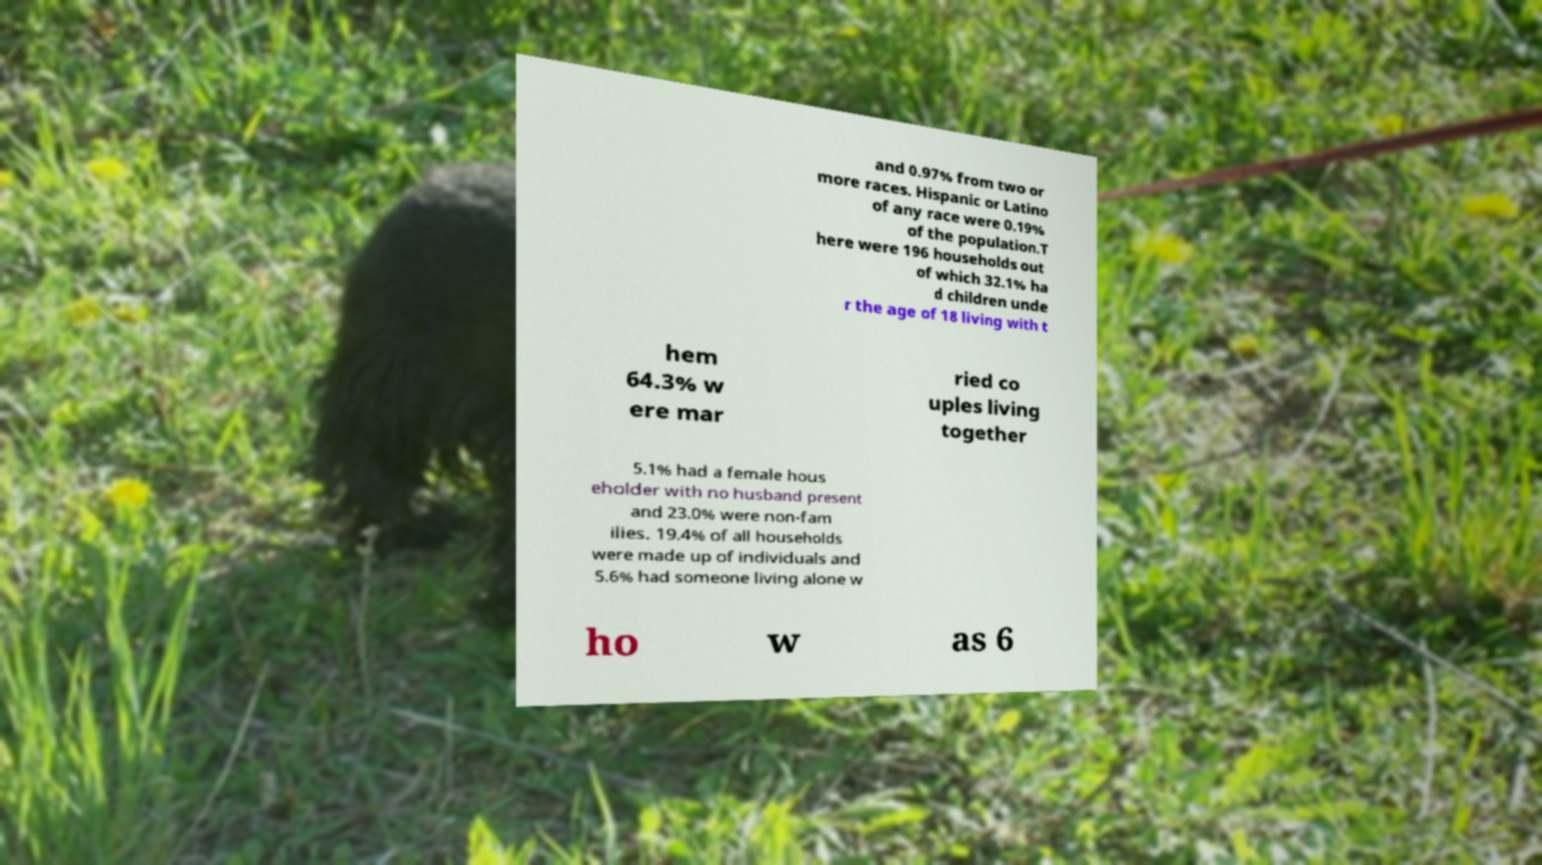Can you accurately transcribe the text from the provided image for me? and 0.97% from two or more races. Hispanic or Latino of any race were 0.19% of the population.T here were 196 households out of which 32.1% ha d children unde r the age of 18 living with t hem 64.3% w ere mar ried co uples living together 5.1% had a female hous eholder with no husband present and 23.0% were non-fam ilies. 19.4% of all households were made up of individuals and 5.6% had someone living alone w ho w as 6 